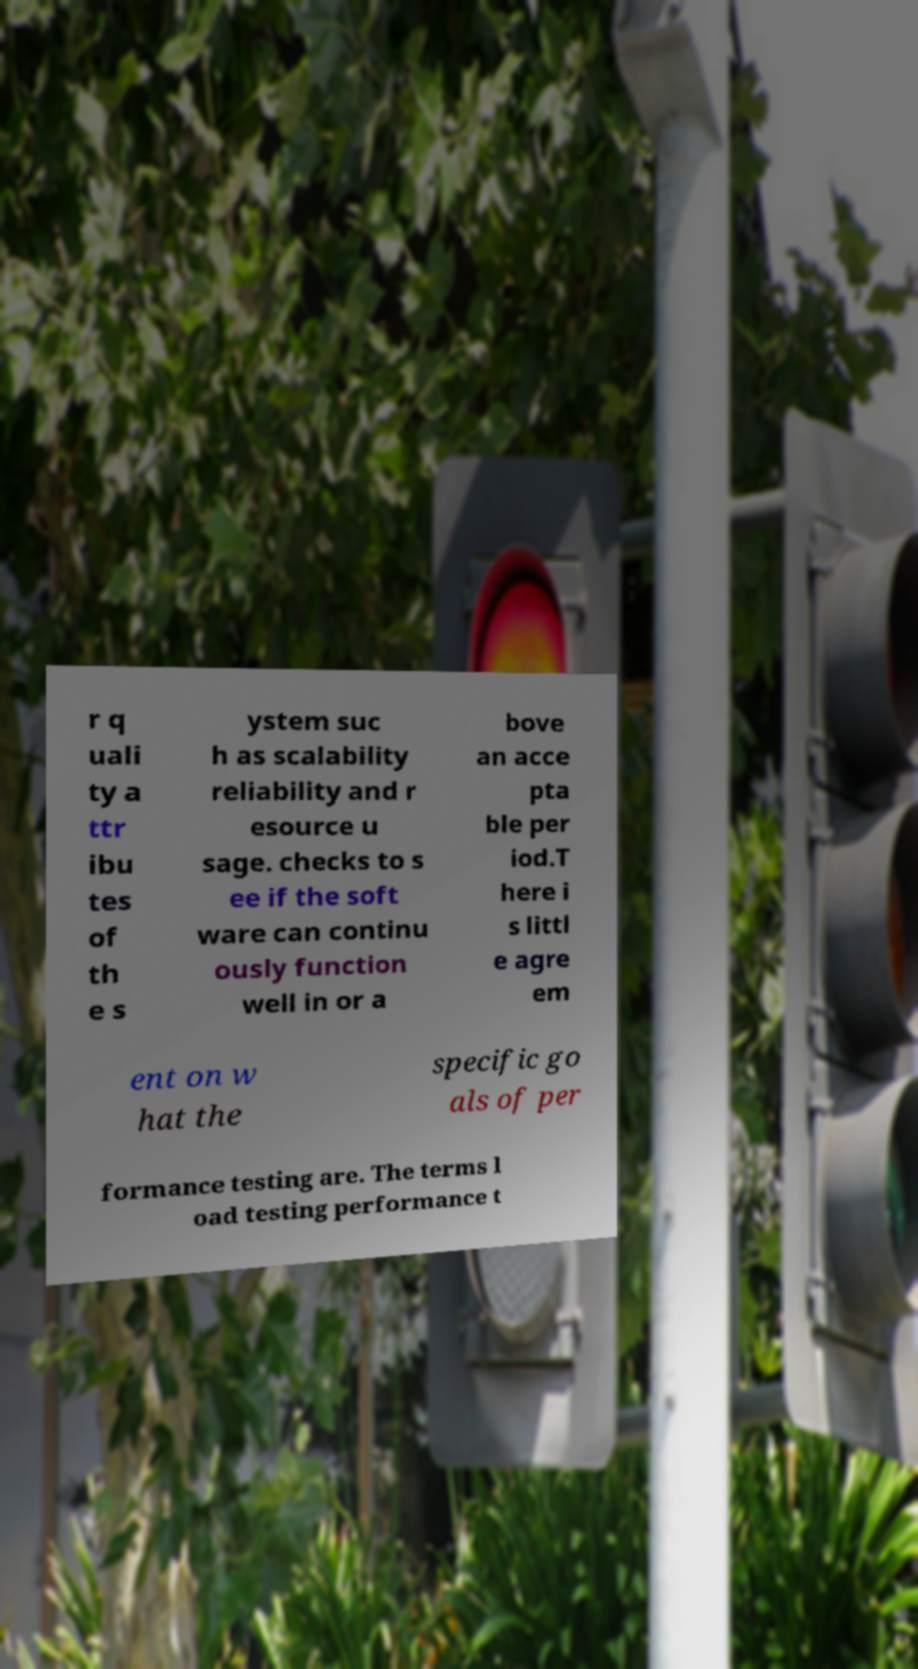Could you assist in decoding the text presented in this image and type it out clearly? r q uali ty a ttr ibu tes of th e s ystem suc h as scalability reliability and r esource u sage. checks to s ee if the soft ware can continu ously function well in or a bove an acce pta ble per iod.T here i s littl e agre em ent on w hat the specific go als of per formance testing are. The terms l oad testing performance t 